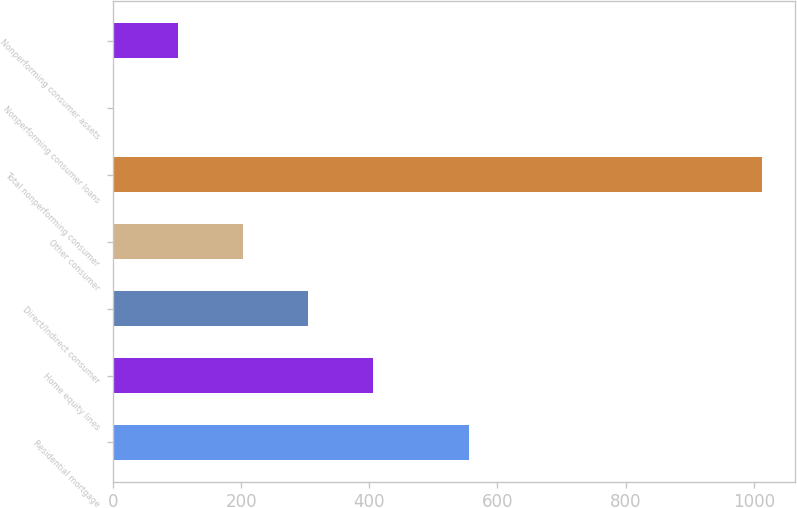Convert chart to OTSL. <chart><loc_0><loc_0><loc_500><loc_500><bar_chart><fcel>Residential mortgage<fcel>Home equity lines<fcel>Direct/Indirect consumer<fcel>Other consumer<fcel>Total nonperforming consumer<fcel>Nonperforming consumer loans<fcel>Nonperforming consumer assets<nl><fcel>556<fcel>405.45<fcel>304.19<fcel>202.93<fcel>1013<fcel>0.41<fcel>101.67<nl></chart> 